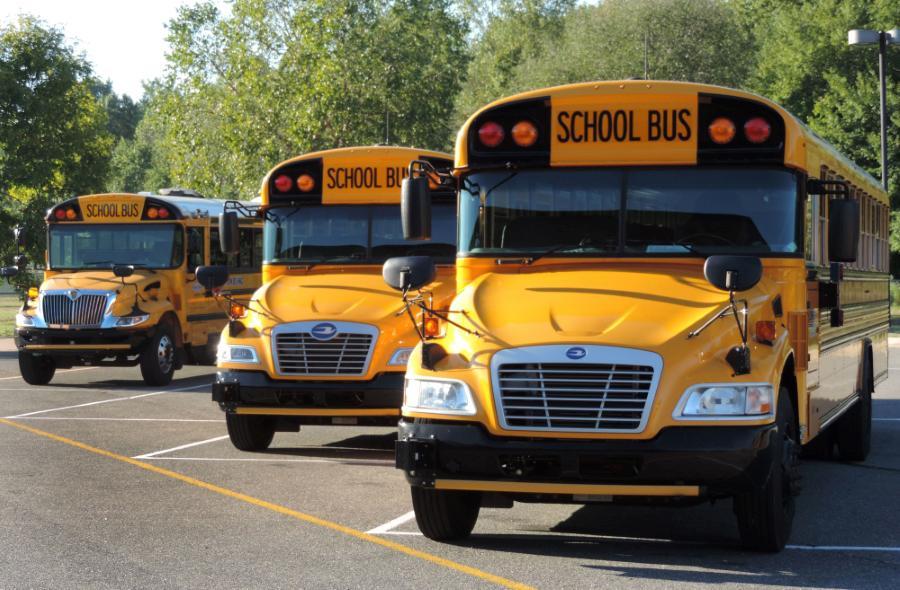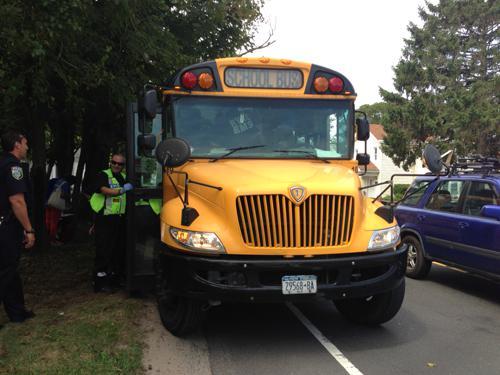The first image is the image on the left, the second image is the image on the right. Evaluate the accuracy of this statement regarding the images: "The right image shows at least one person standing on a curb by the open door of a parked yellow bus with a non-flat front.". Is it true? Answer yes or no. Yes. The first image is the image on the left, the second image is the image on the right. Considering the images on both sides, is "People are standing outside the bus in the image on the right." valid? Answer yes or no. Yes. 